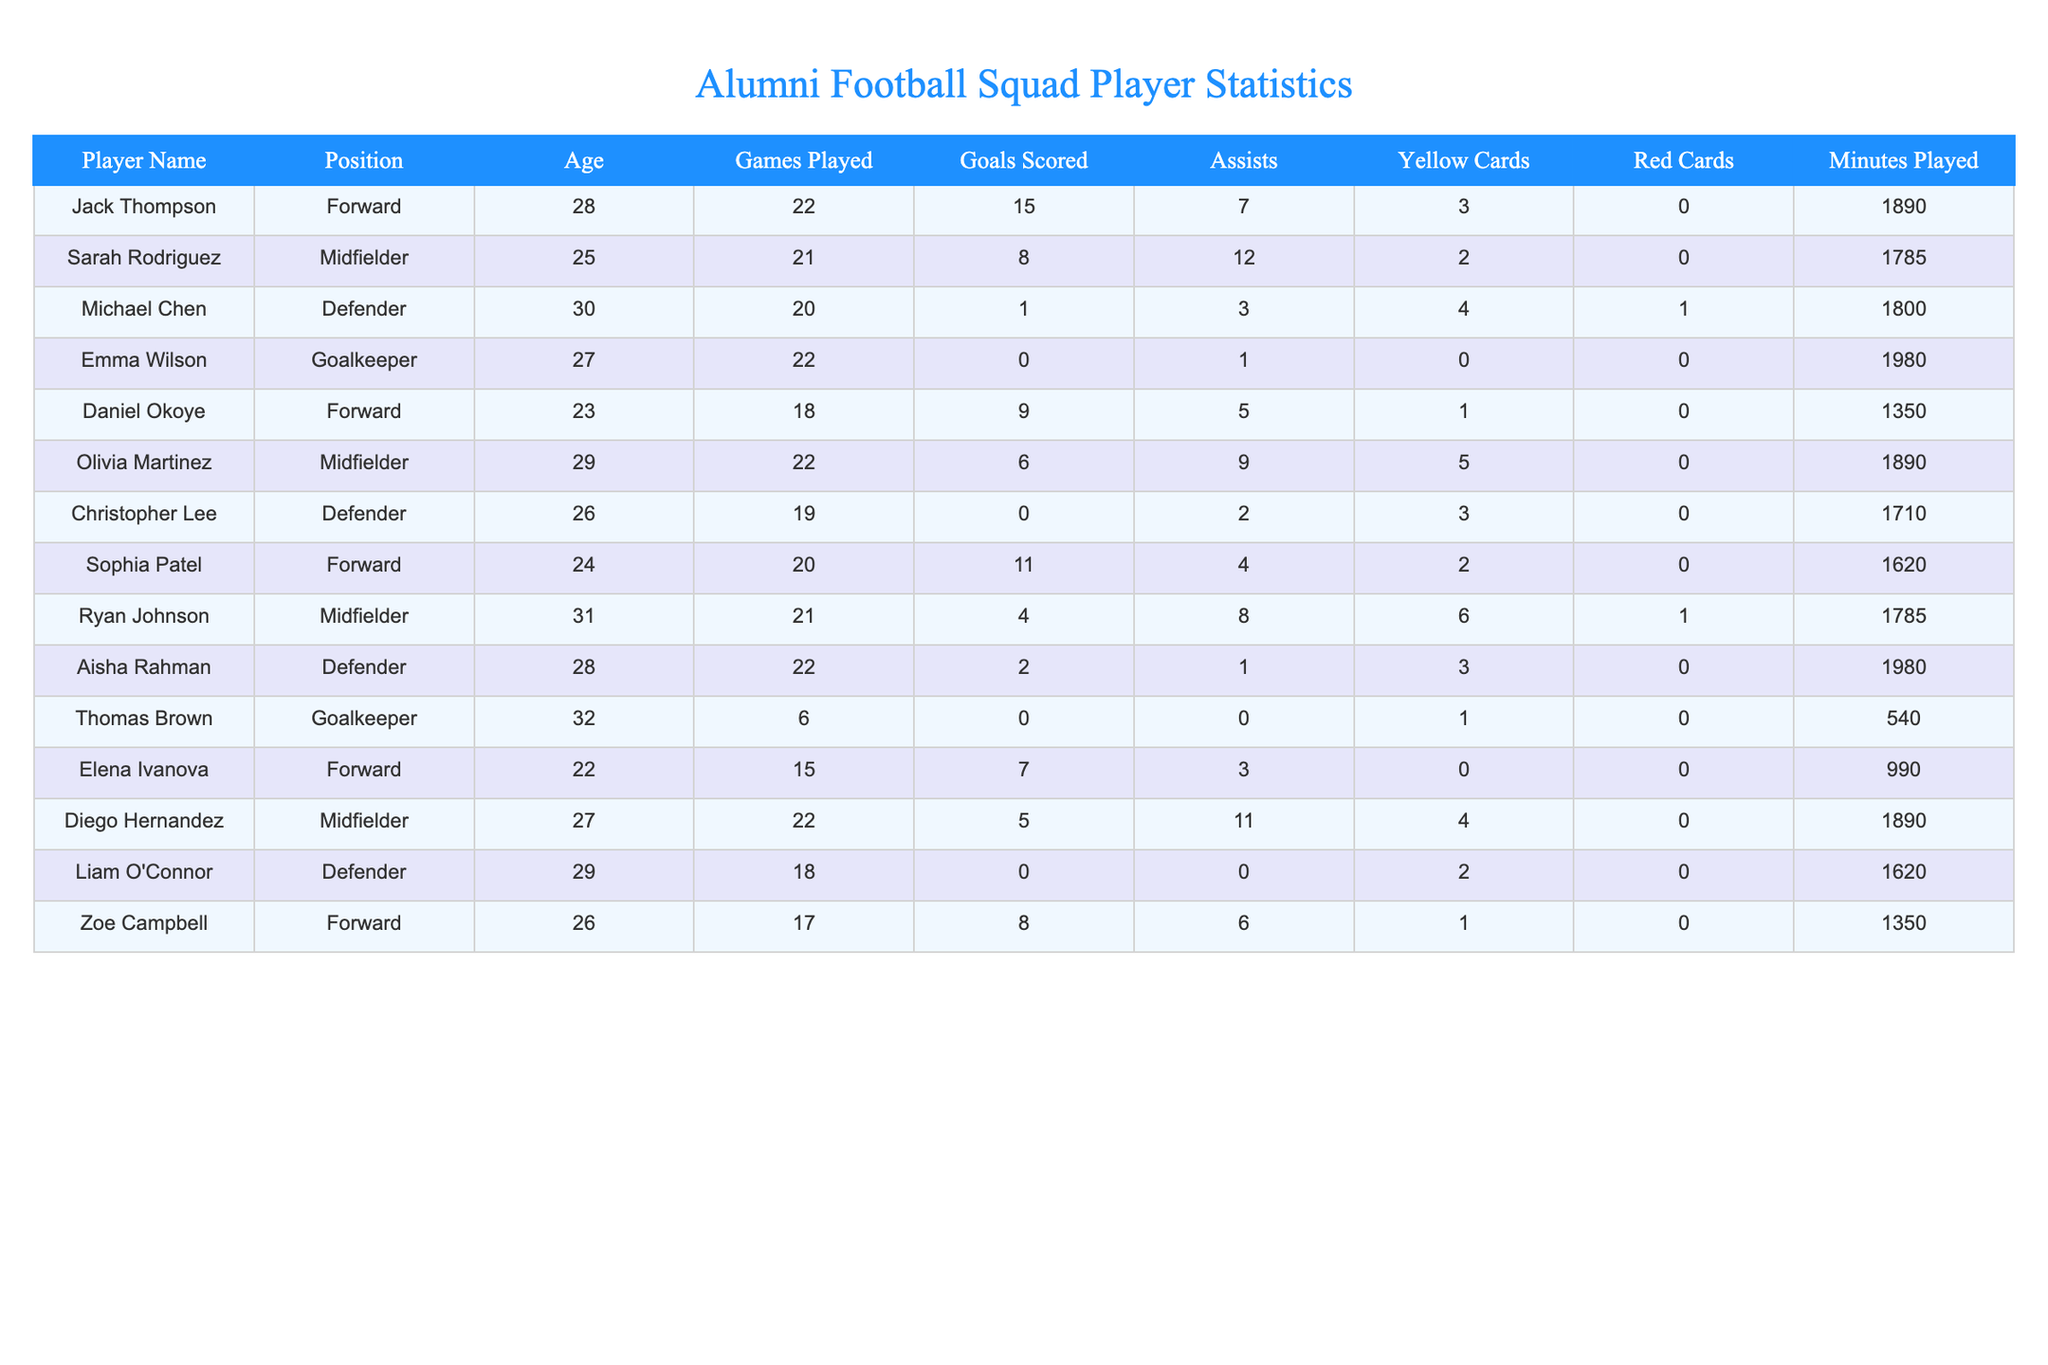What is the total number of goals scored by all forwards? To find the total number of goals scored by all forwards, I will add the goals scored by Jack Thompson (15), Daniel Okoye (9), Sophia Patel (11), Elena Ivanova (7), and Zoe Campbell (8). The total is 15 + 9 + 11 + 7 + 8 = 50.
Answer: 50 Which player has the most assists? I will look through the assists column to find the highest number. Sarah Rodriguez has 12 assists, which is more than any other player.
Answer: Sarah Rodriguez What is the average age of the players on the team? First, I need to sum the ages of all players: (28 + 25 + 30 + 27 + 23 + 29 + 26 + 24 + 31 + 28 + 32 + 22 + 27 + 29 + 26) = 402. There are 15 players, so the average age is 402 / 15 = 26.8.
Answer: 26.8 How many players have received yellow cards? I will count the number of players with a yellow card count greater than 0 from the table. Jack Thompson (3), Sarah Rodriguez (2), Michael Chen (4), Olivia Martinez (5), Ryan Johnson (6), Aisha Rahman (3), and Christopher Lee (3) means a total of 7 players have received yellow cards.
Answer: 7 Is there a player who has scored more goals than they have assists? I will compare the goals and assists of each player. Jack Thompson (15 goals, 7 assists), Daniel Okoye (9 goals, 5 assists), and Sophia Patel (11 goals, 4 assists) have more goals than assists. Therefore, the answer is yes.
Answer: Yes Which position has the most players on the team? I will count the number of players in each position from the table. There are 5 forwards, 5 midfielders, 4 defenders, and 2 goalkeepers. Therefore, forwards and midfielders are tied for the most players.
Answer: Forwards and Midfielders What is the total number of minutes played by the defenders? I will add the minutes played by each defender: Michael Chen (1800), Christopher Lee (1710), Liam O'Connor (1620), and Aisha Rahman (1980). The total minutes played by defenders is 1800 + 1710 + 1620 + 1980 = 7110.
Answer: 7110 Who is the oldest player on the team? I need to look for the maximum value in the age column. The oldest player is Thomas Brown, who is 32 years old.
Answer: Thomas Brown What is the difference in goals scored between the highest scoring player and the lowest? Jack Thompson has the highest goals scored with 15, and Thomas Brown has 0. The difference is 15 - 0 = 15.
Answer: 15 How many players have played more than 20 games this season? I will count the players who have played more than 20 games: Jack Thompson (22), Emma Wilson (22), Olivia Martinez (22), Aisha Rahman (22), Daniel Okoye (18 is not qualifying), Diego Hernandez (22), Zoe Campbell (17 is not qualifying), Sarah Rodriguez (21), and Ryan Johnson (21). The total is 6 players.
Answer: 6 